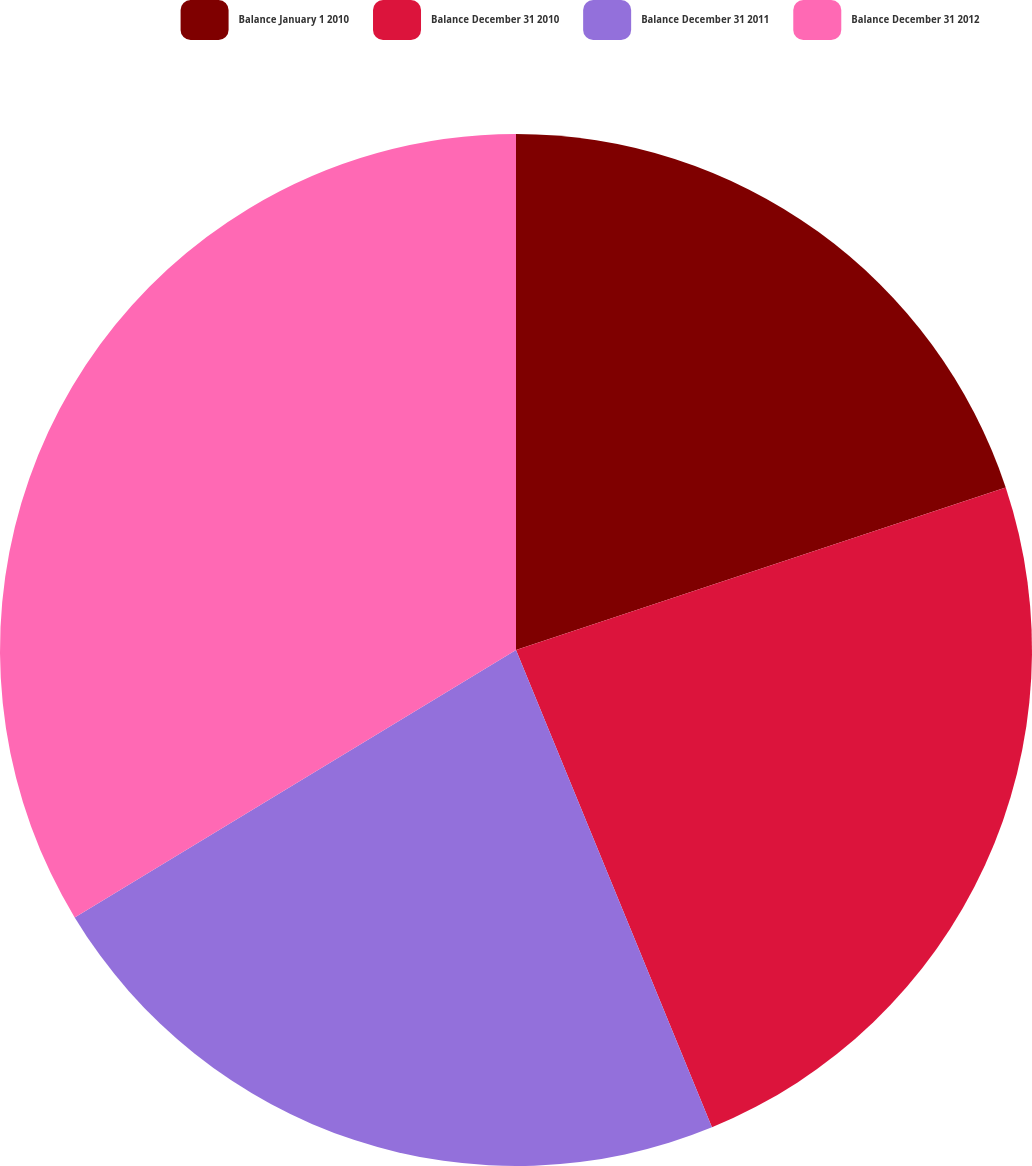Convert chart to OTSL. <chart><loc_0><loc_0><loc_500><loc_500><pie_chart><fcel>Balance January 1 2010<fcel>Balance December 31 2010<fcel>Balance December 31 2011<fcel>Balance December 31 2012<nl><fcel>19.9%<fcel>23.9%<fcel>22.53%<fcel>33.67%<nl></chart> 